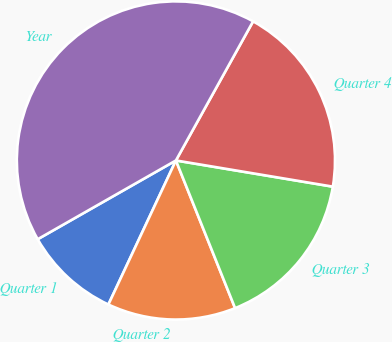Convert chart. <chart><loc_0><loc_0><loc_500><loc_500><pie_chart><fcel>Quarter 1<fcel>Quarter 2<fcel>Quarter 3<fcel>Quarter 4<fcel>Year<nl><fcel>9.78%<fcel>13.04%<fcel>16.3%<fcel>19.57%<fcel>41.3%<nl></chart> 